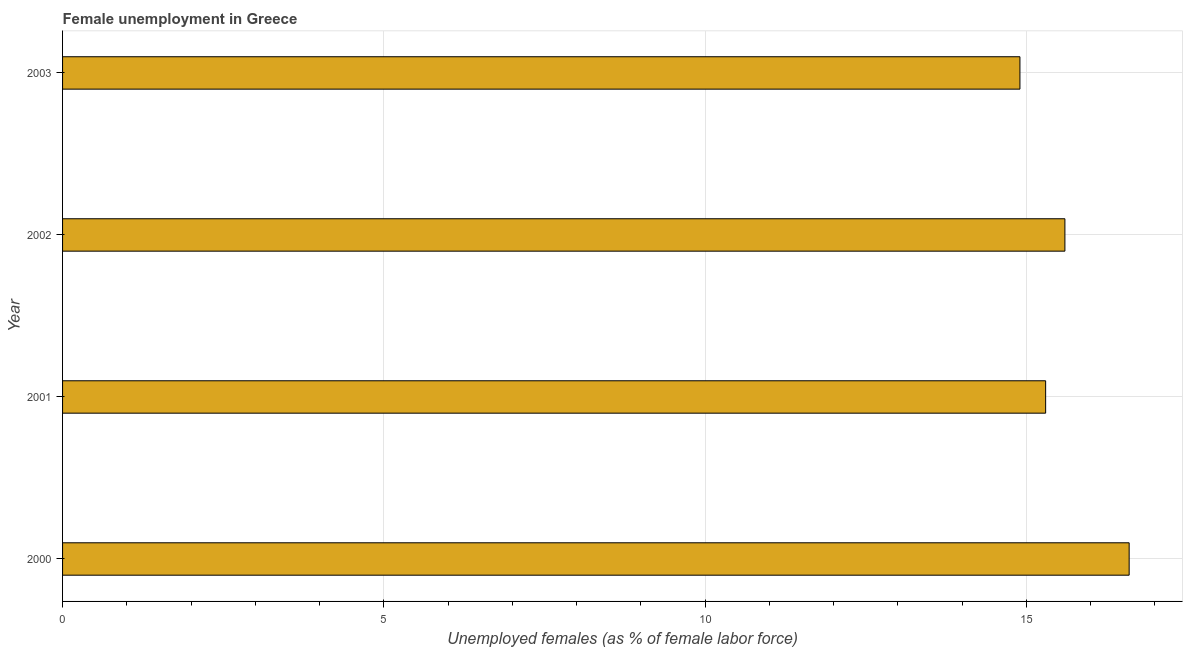Does the graph contain any zero values?
Your answer should be very brief. No. Does the graph contain grids?
Offer a terse response. Yes. What is the title of the graph?
Your answer should be very brief. Female unemployment in Greece. What is the label or title of the X-axis?
Ensure brevity in your answer.  Unemployed females (as % of female labor force). What is the unemployed females population in 2000?
Your response must be concise. 16.6. Across all years, what is the maximum unemployed females population?
Provide a short and direct response. 16.6. Across all years, what is the minimum unemployed females population?
Give a very brief answer. 14.9. In which year was the unemployed females population minimum?
Make the answer very short. 2003. What is the sum of the unemployed females population?
Make the answer very short. 62.4. What is the difference between the unemployed females population in 2000 and 2001?
Your answer should be compact. 1.3. What is the median unemployed females population?
Keep it short and to the point. 15.45. Do a majority of the years between 2000 and 2001 (inclusive) have unemployed females population greater than 3 %?
Provide a short and direct response. Yes. What is the ratio of the unemployed females population in 2002 to that in 2003?
Make the answer very short. 1.05. Is the unemployed females population in 2001 less than that in 2002?
Make the answer very short. Yes. What is the difference between the highest and the lowest unemployed females population?
Offer a very short reply. 1.7. What is the difference between two consecutive major ticks on the X-axis?
Your answer should be very brief. 5. What is the Unemployed females (as % of female labor force) of 2000?
Ensure brevity in your answer.  16.6. What is the Unemployed females (as % of female labor force) of 2001?
Keep it short and to the point. 15.3. What is the Unemployed females (as % of female labor force) of 2002?
Your answer should be compact. 15.6. What is the Unemployed females (as % of female labor force) of 2003?
Keep it short and to the point. 14.9. What is the difference between the Unemployed females (as % of female labor force) in 2000 and 2003?
Give a very brief answer. 1.7. What is the difference between the Unemployed females (as % of female labor force) in 2001 and 2002?
Keep it short and to the point. -0.3. What is the ratio of the Unemployed females (as % of female labor force) in 2000 to that in 2001?
Make the answer very short. 1.08. What is the ratio of the Unemployed females (as % of female labor force) in 2000 to that in 2002?
Offer a very short reply. 1.06. What is the ratio of the Unemployed females (as % of female labor force) in 2000 to that in 2003?
Keep it short and to the point. 1.11. What is the ratio of the Unemployed females (as % of female labor force) in 2002 to that in 2003?
Provide a succinct answer. 1.05. 